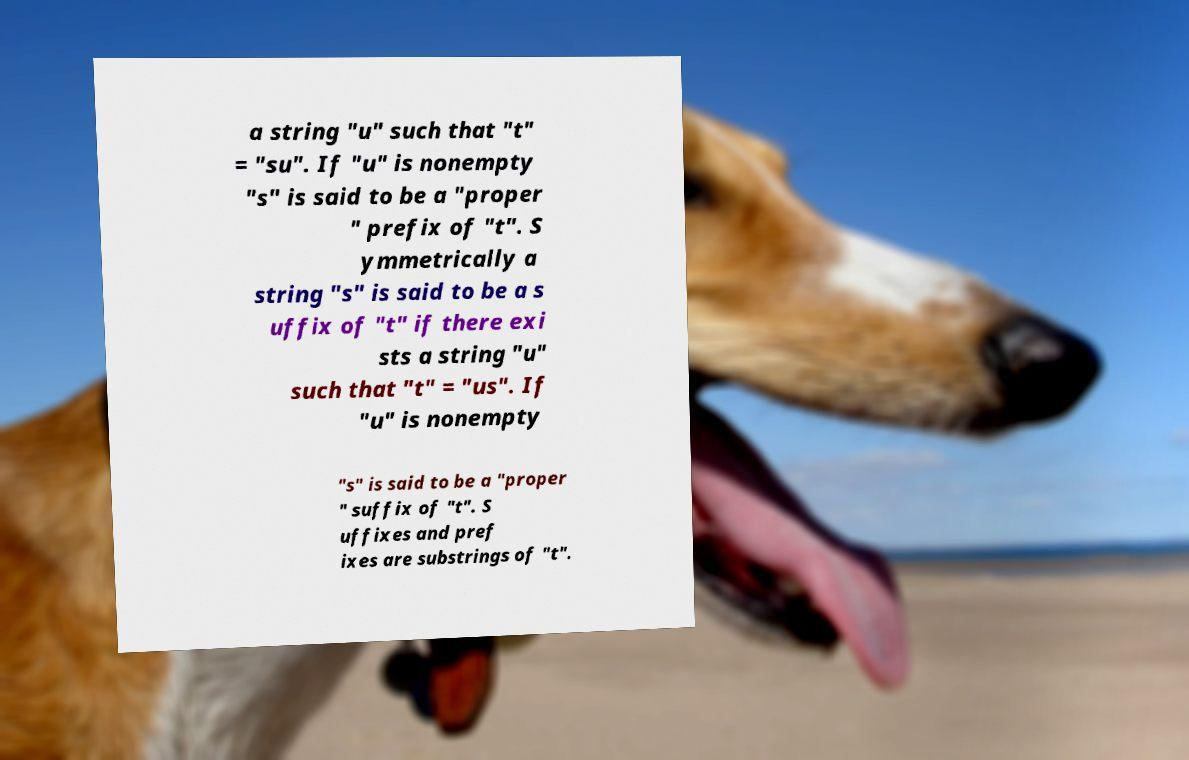Could you extract and type out the text from this image? a string "u" such that "t" = "su". If "u" is nonempty "s" is said to be a "proper " prefix of "t". S ymmetrically a string "s" is said to be a s uffix of "t" if there exi sts a string "u" such that "t" = "us". If "u" is nonempty "s" is said to be a "proper " suffix of "t". S uffixes and pref ixes are substrings of "t". 